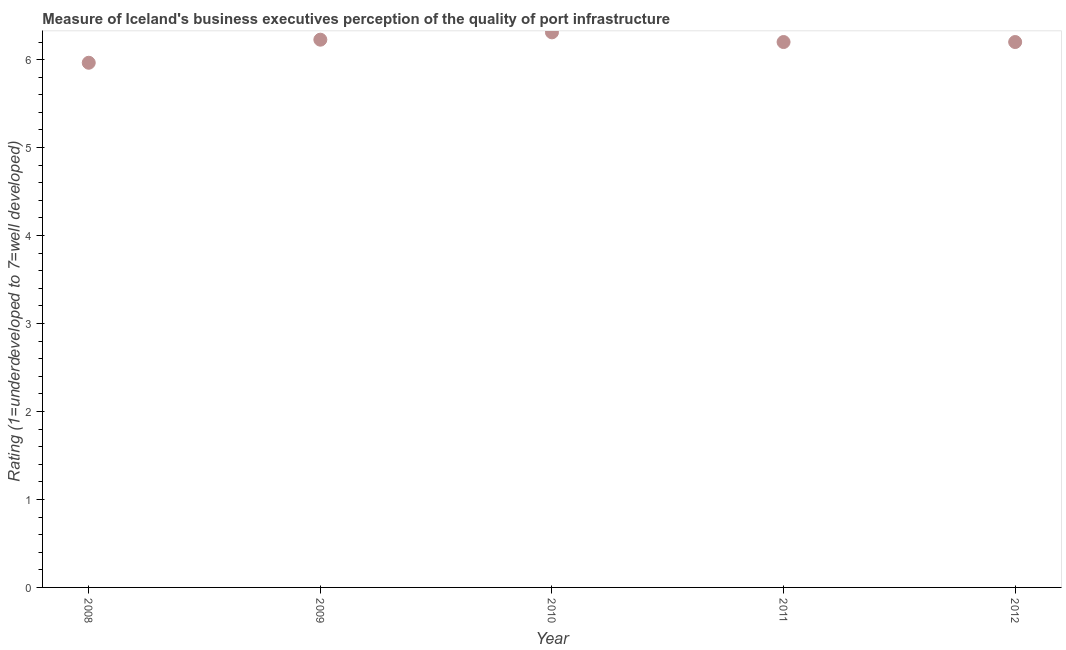What is the rating measuring quality of port infrastructure in 2009?
Your answer should be compact. 6.23. Across all years, what is the maximum rating measuring quality of port infrastructure?
Your response must be concise. 6.31. Across all years, what is the minimum rating measuring quality of port infrastructure?
Offer a terse response. 5.96. In which year was the rating measuring quality of port infrastructure minimum?
Ensure brevity in your answer.  2008. What is the sum of the rating measuring quality of port infrastructure?
Provide a short and direct response. 30.9. What is the difference between the rating measuring quality of port infrastructure in 2008 and 2010?
Keep it short and to the point. -0.35. What is the average rating measuring quality of port infrastructure per year?
Ensure brevity in your answer.  6.18. What is the median rating measuring quality of port infrastructure?
Provide a succinct answer. 6.2. Do a majority of the years between 2011 and 2010 (inclusive) have rating measuring quality of port infrastructure greater than 1 ?
Make the answer very short. No. What is the ratio of the rating measuring quality of port infrastructure in 2010 to that in 2011?
Make the answer very short. 1.02. Is the rating measuring quality of port infrastructure in 2009 less than that in 2011?
Ensure brevity in your answer.  No. Is the difference between the rating measuring quality of port infrastructure in 2008 and 2010 greater than the difference between any two years?
Offer a terse response. Yes. What is the difference between the highest and the second highest rating measuring quality of port infrastructure?
Your answer should be very brief. 0.08. What is the difference between the highest and the lowest rating measuring quality of port infrastructure?
Provide a succinct answer. 0.35. How many years are there in the graph?
Your answer should be compact. 5. What is the difference between two consecutive major ticks on the Y-axis?
Make the answer very short. 1. Does the graph contain any zero values?
Your response must be concise. No. Does the graph contain grids?
Give a very brief answer. No. What is the title of the graph?
Keep it short and to the point. Measure of Iceland's business executives perception of the quality of port infrastructure. What is the label or title of the X-axis?
Your response must be concise. Year. What is the label or title of the Y-axis?
Offer a very short reply. Rating (1=underdeveloped to 7=well developed) . What is the Rating (1=underdeveloped to 7=well developed)  in 2008?
Offer a very short reply. 5.96. What is the Rating (1=underdeveloped to 7=well developed)  in 2009?
Offer a very short reply. 6.23. What is the Rating (1=underdeveloped to 7=well developed)  in 2010?
Your answer should be very brief. 6.31. What is the Rating (1=underdeveloped to 7=well developed)  in 2011?
Offer a terse response. 6.2. What is the difference between the Rating (1=underdeveloped to 7=well developed)  in 2008 and 2009?
Your answer should be very brief. -0.26. What is the difference between the Rating (1=underdeveloped to 7=well developed)  in 2008 and 2010?
Keep it short and to the point. -0.35. What is the difference between the Rating (1=underdeveloped to 7=well developed)  in 2008 and 2011?
Provide a short and direct response. -0.24. What is the difference between the Rating (1=underdeveloped to 7=well developed)  in 2008 and 2012?
Ensure brevity in your answer.  -0.24. What is the difference between the Rating (1=underdeveloped to 7=well developed)  in 2009 and 2010?
Offer a terse response. -0.08. What is the difference between the Rating (1=underdeveloped to 7=well developed)  in 2009 and 2011?
Your response must be concise. 0.03. What is the difference between the Rating (1=underdeveloped to 7=well developed)  in 2009 and 2012?
Provide a succinct answer. 0.03. What is the difference between the Rating (1=underdeveloped to 7=well developed)  in 2010 and 2011?
Give a very brief answer. 0.11. What is the difference between the Rating (1=underdeveloped to 7=well developed)  in 2010 and 2012?
Your answer should be compact. 0.11. What is the ratio of the Rating (1=underdeveloped to 7=well developed)  in 2008 to that in 2009?
Offer a very short reply. 0.96. What is the ratio of the Rating (1=underdeveloped to 7=well developed)  in 2008 to that in 2010?
Offer a terse response. 0.94. What is the ratio of the Rating (1=underdeveloped to 7=well developed)  in 2009 to that in 2010?
Keep it short and to the point. 0.99. What is the ratio of the Rating (1=underdeveloped to 7=well developed)  in 2009 to that in 2012?
Offer a terse response. 1. What is the ratio of the Rating (1=underdeveloped to 7=well developed)  in 2010 to that in 2011?
Provide a succinct answer. 1.02. What is the ratio of the Rating (1=underdeveloped to 7=well developed)  in 2010 to that in 2012?
Make the answer very short. 1.02. What is the ratio of the Rating (1=underdeveloped to 7=well developed)  in 2011 to that in 2012?
Offer a very short reply. 1. 